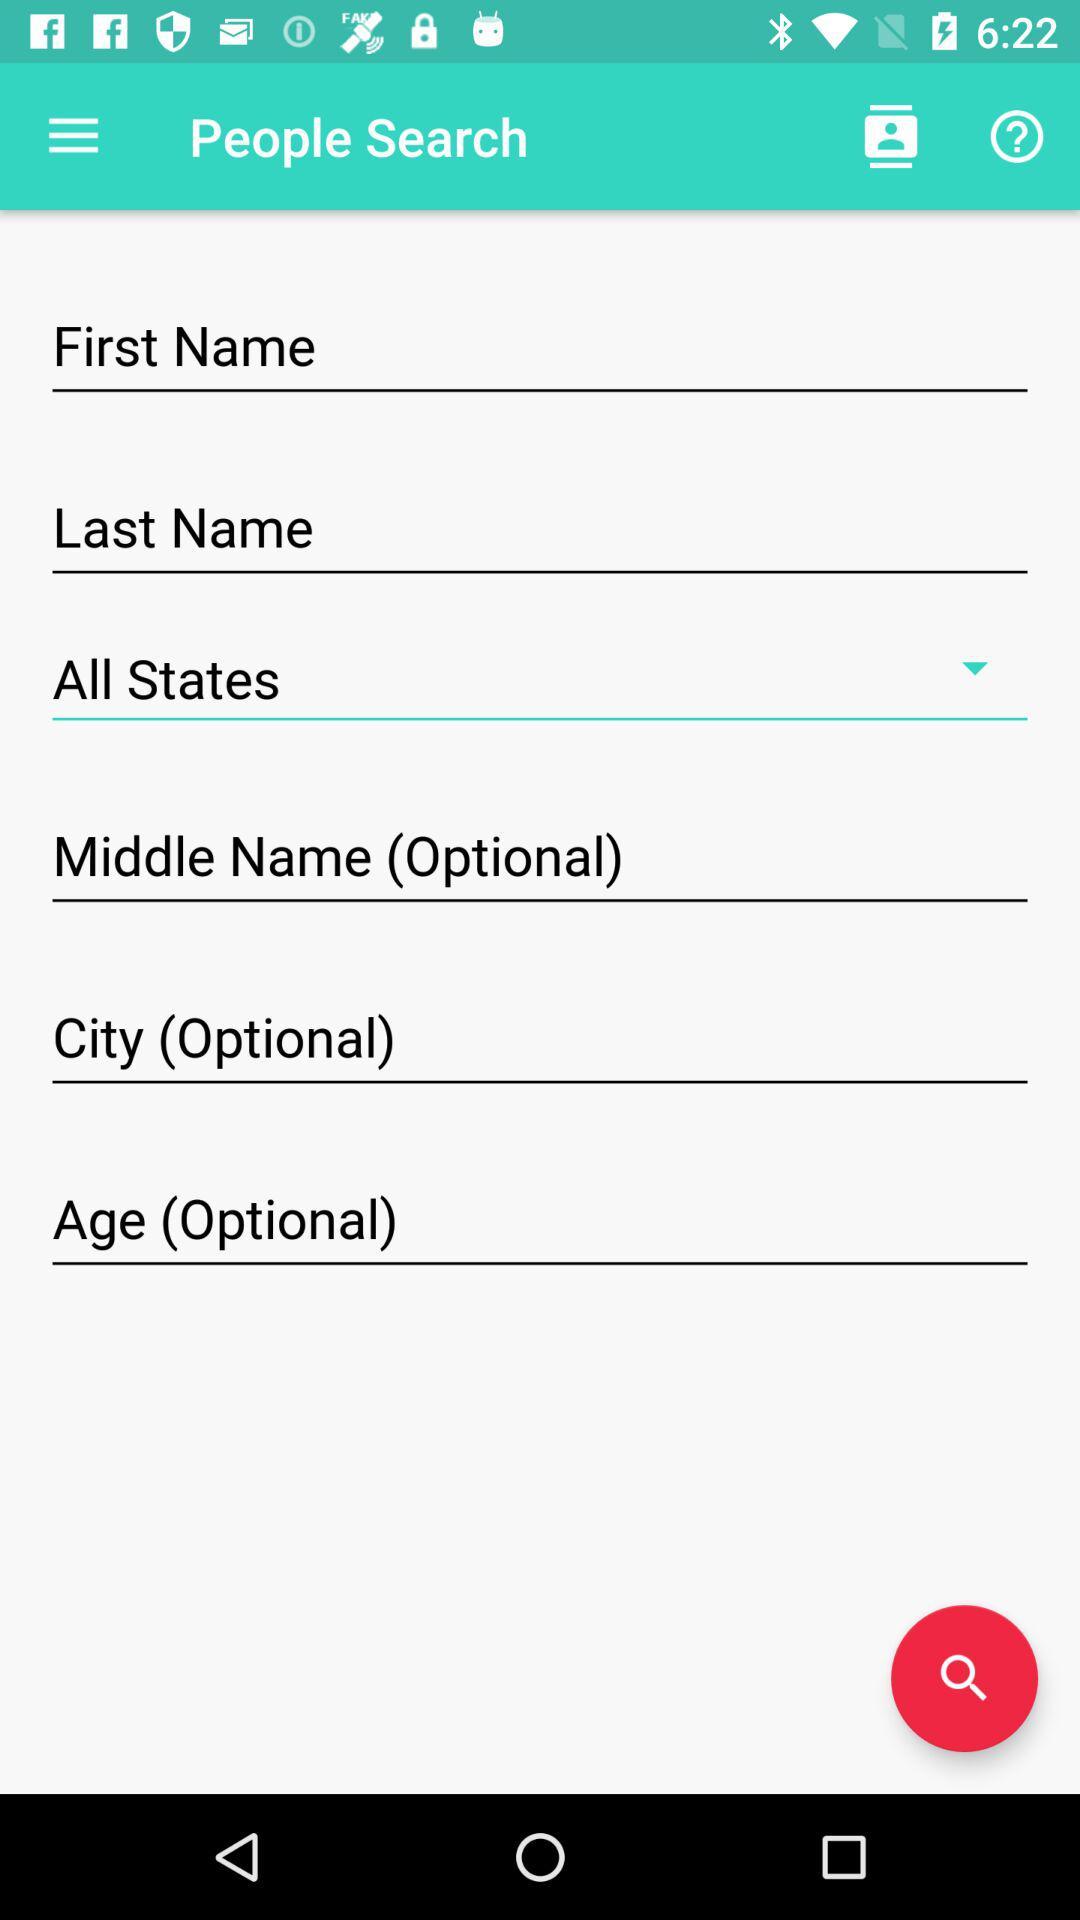How many text inputs allow users to enter optional information?
Answer the question using a single word or phrase. 3 